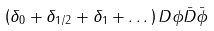Convert formula to latex. <formula><loc_0><loc_0><loc_500><loc_500>\left ( \delta _ { 0 } + \delta _ { 1 / 2 } + \delta _ { 1 } + \dots \right ) D \phi \bar { D } \bar { \phi }</formula> 